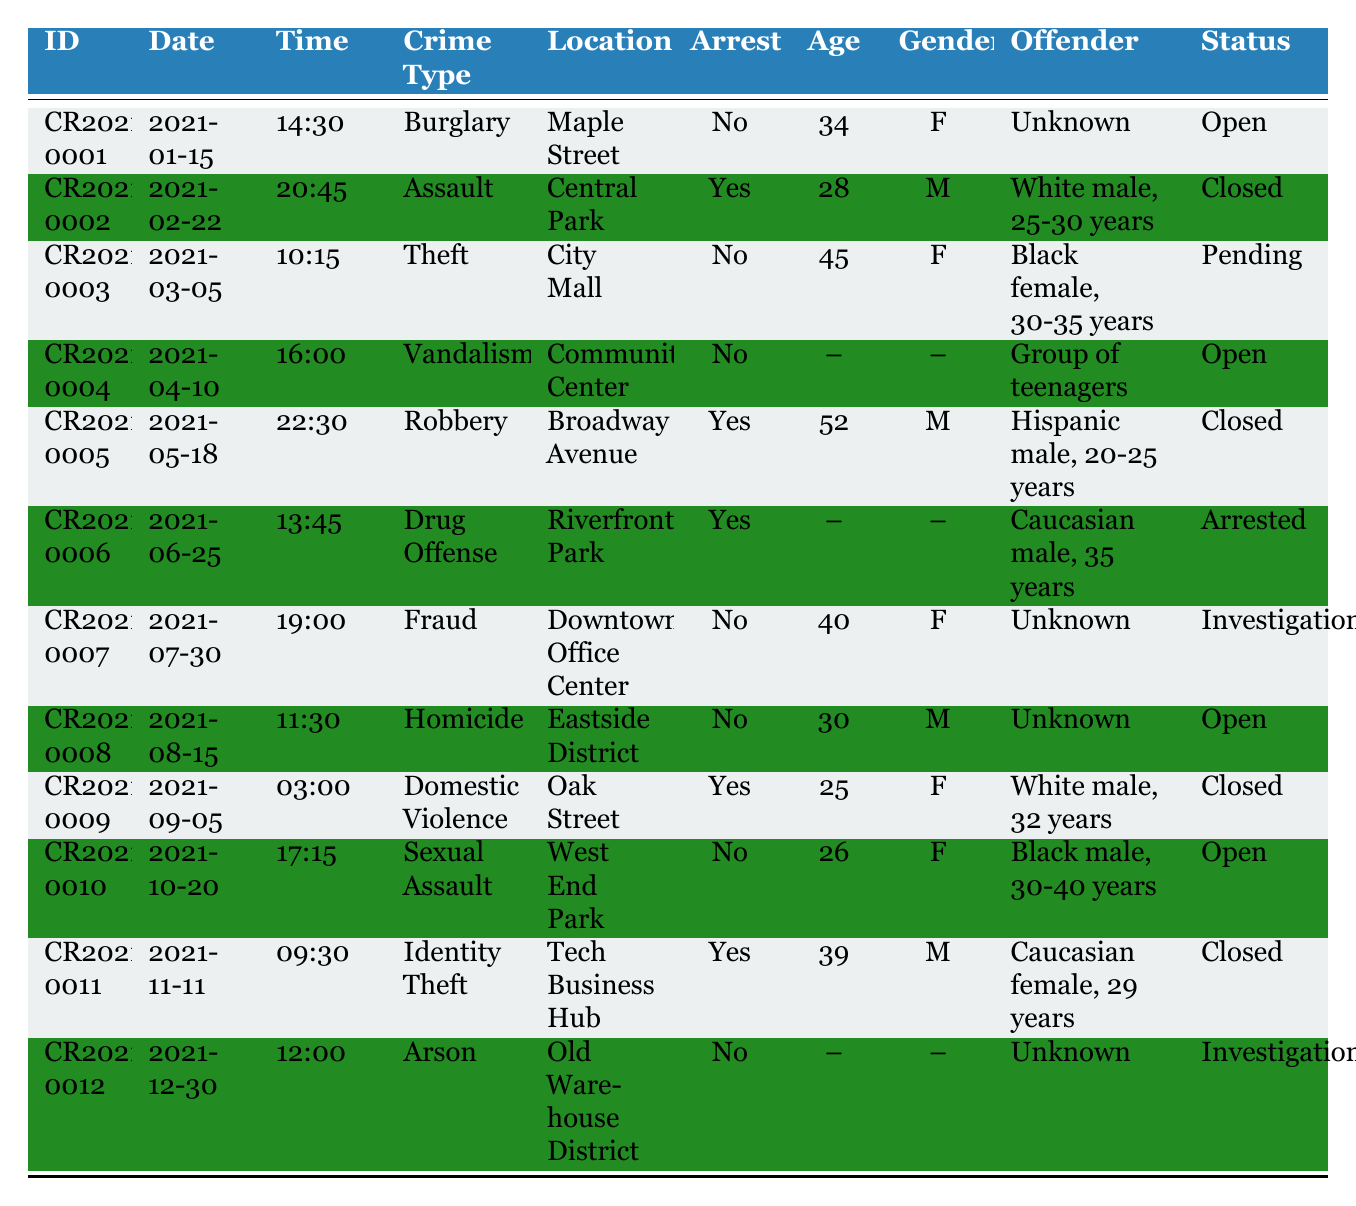What is the total number of incidents listed in the table? The table contains 12 rows of data, each representing an incident. Thus, the total number of incidents is simply counted as 12.
Answer: 12 How many different types of crimes are recorded in the data? By reviewing the "Crime Type" column, we can identify the unique types of crimes which include Burglary, Assault, Theft, Vandalism, Robbery, Drug Offense, Fraud, Homicide, Domestic Violence, Sexual Assault, Identity Theft, and Arson. There are 12 different crime types.
Answer: 12 Which incident has the latest date recorded? To find the latest date, we check all the entries in the "Date" column. The date "2021-12-30" is the latest among all.
Answer: 2021-12-30 How many arrests were made according to this report? We can count the "Arrest" column where it is marked as "Yes". There are 5 incidents with an arrest made.
Answer: 5 What percentage of incidents resulted in an arrest? To calculate the percentage, we know there are 12 total incidents (from the first question) and 5 arrests made. The percentage is (5 / 12) * 100, which equals approximately 41.67%.
Answer: 41.67% How many crimes remain open according to the report? By inspecting the "Status" column, we see that 5 incidents have the status "Open" among the total 12.
Answer: 5 Is there any incident with a victim's gender noted as "Female" that was closed? We check for entries where "Gender" is "F" and "Status" is "Closed". The incident CR2021-0002 is the one that matches both criteria.
Answer: Yes Which crime type had the highest number of incidents that ended in arrest? By counting the number of arrests for each crime type: Assault (1), Robbery (1), Drug Offense (1), Domestic Violence (1), and Identity Theft (1). Each has one arrest, but no crime type has more than one incident leading to an arrest.
Answer: All relevant crime types equally had one incident with an arrest How many incidents involved victims aged 30 years or older? Looking at the "Victim Age" column, we find the ages that are 30 and older: 34, 45, 52, 40, 30, 25, and 39. This results in 6 incidents with victims aged 30 or older.
Answer: 6 What is the case status of the robbery incident? The incident with the crime type "Robbery" is CR2021-0005, and its status can be found in the "Status" column, which indicates "Closed".
Answer: Closed 